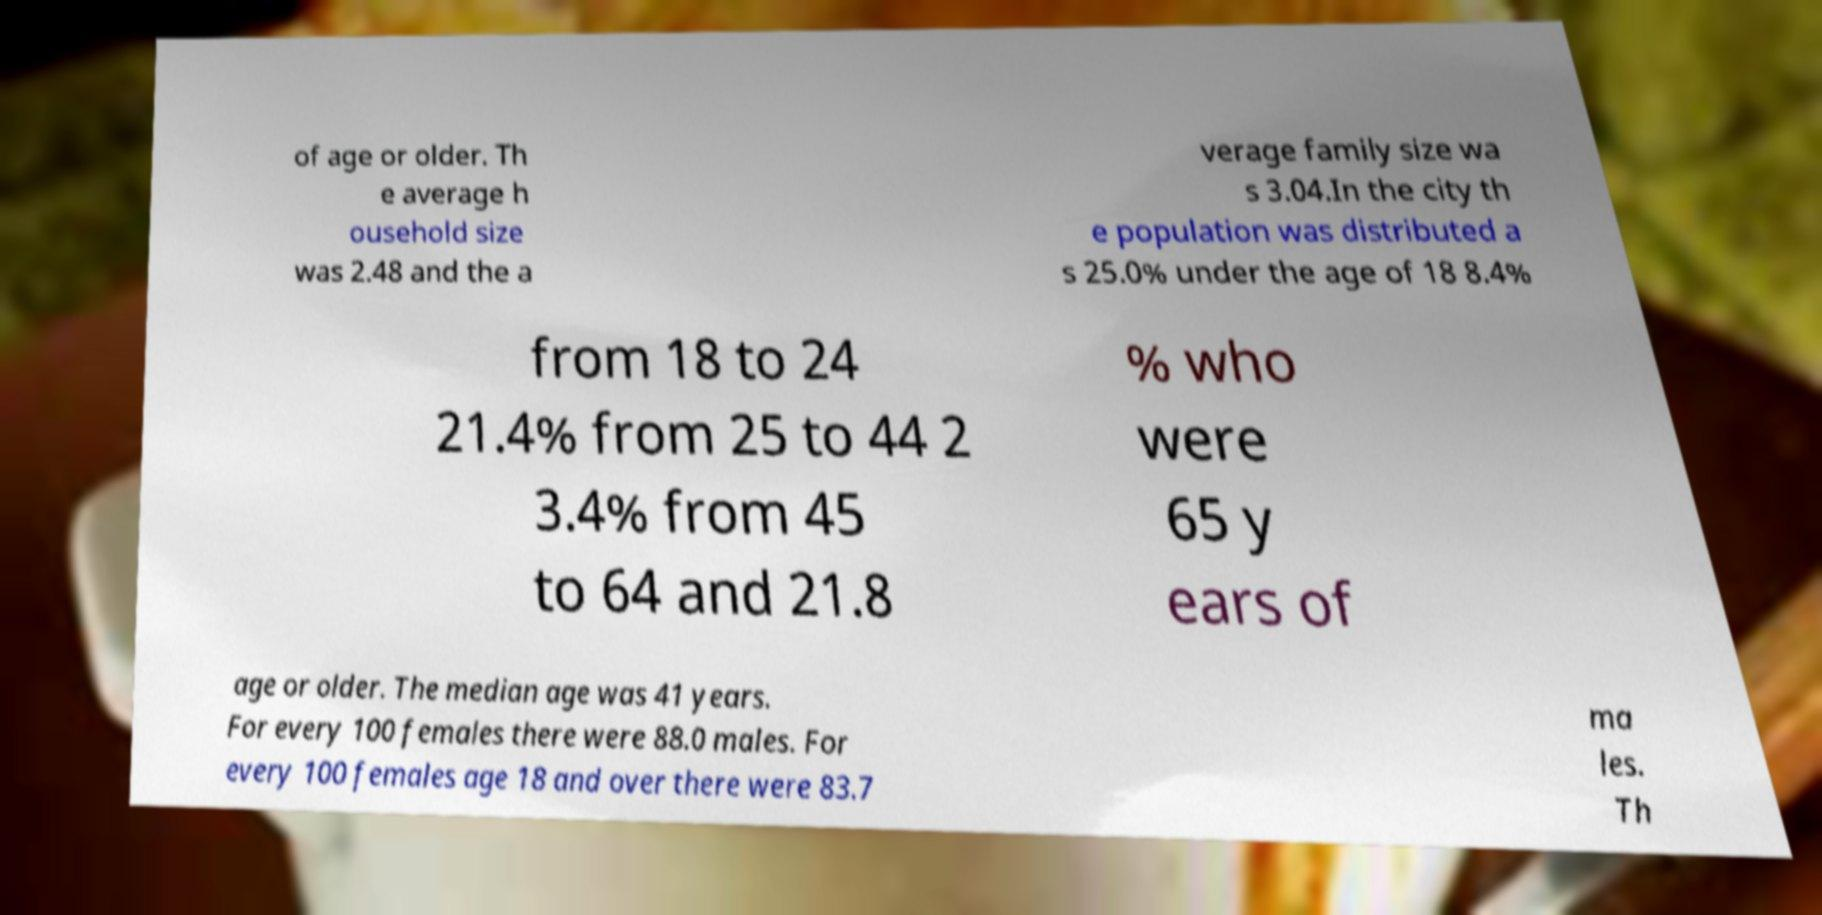Can you read and provide the text displayed in the image?This photo seems to have some interesting text. Can you extract and type it out for me? of age or older. Th e average h ousehold size was 2.48 and the a verage family size wa s 3.04.In the city th e population was distributed a s 25.0% under the age of 18 8.4% from 18 to 24 21.4% from 25 to 44 2 3.4% from 45 to 64 and 21.8 % who were 65 y ears of age or older. The median age was 41 years. For every 100 females there were 88.0 males. For every 100 females age 18 and over there were 83.7 ma les. Th 